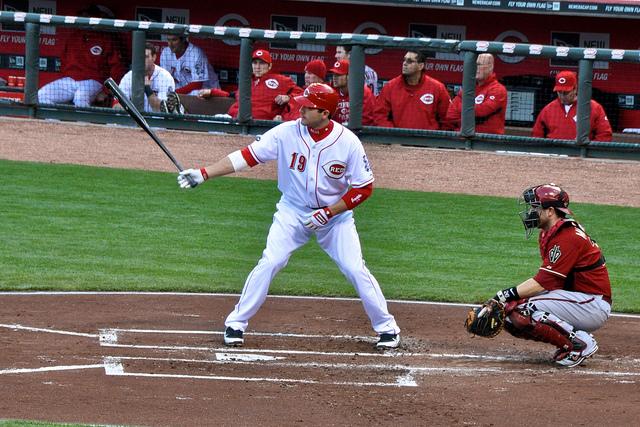What Color is the man's uniform?
Give a very brief answer. White. How many people are standing behind the fence?
Write a very short answer. 10. Is the man in the red helmet hitting the ball?
Short answer required. No. What sport is being played?
Concise answer only. Baseball. What is the man holding?
Keep it brief. Bat. What is the man crouching behind him known as?
Quick response, please. Catcher. 